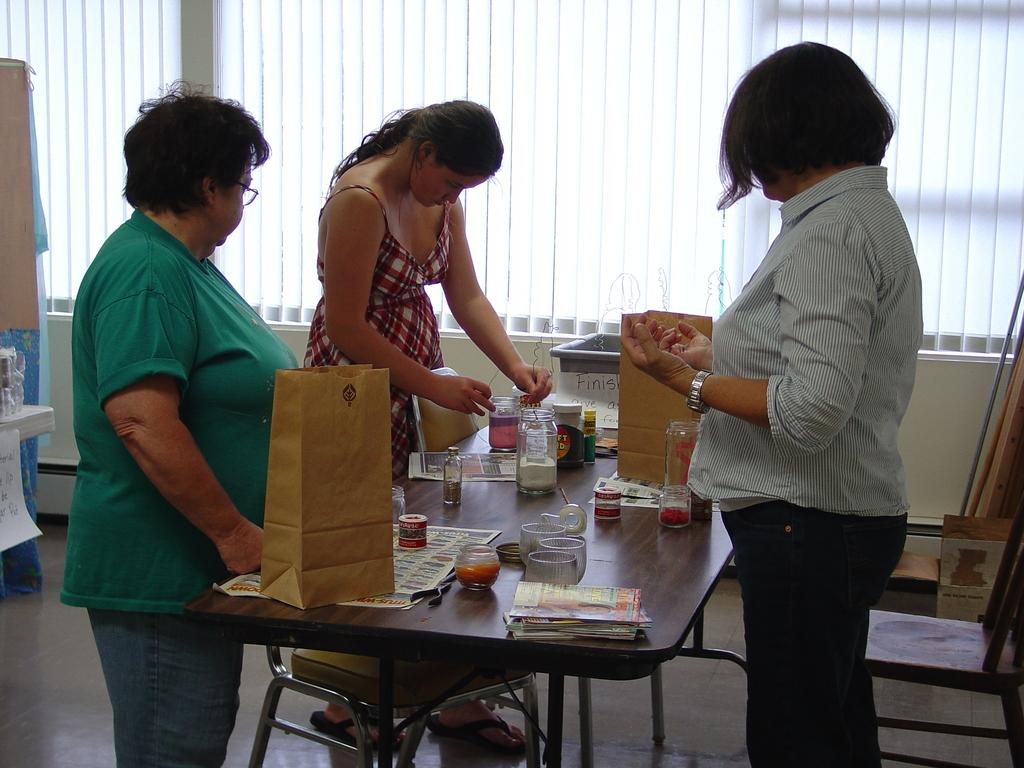How many people are present in the image? There are three people standing in the image. What objects can be seen on the table? There are papers, bags, and bottles on the table. What type of window treatment is visible in the image? There are blinds on the window. What type of pleasure can be seen on the faces of the people in the image? There is no indication of pleasure on the faces of the people in the image, as their expressions are not described in the facts provided. 